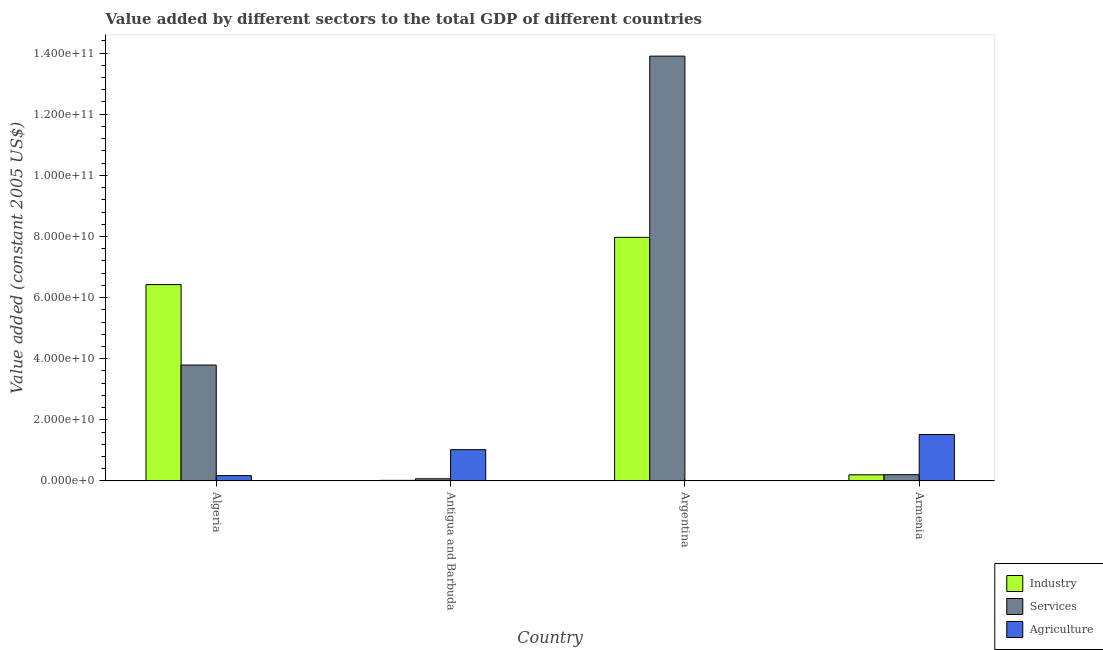How many bars are there on the 4th tick from the left?
Make the answer very short. 3. How many bars are there on the 1st tick from the right?
Offer a very short reply. 3. What is the label of the 4th group of bars from the left?
Make the answer very short. Armenia. What is the value added by agricultural sector in Antigua and Barbuda?
Your answer should be very brief. 1.02e+1. Across all countries, what is the maximum value added by services?
Your answer should be compact. 1.39e+11. Across all countries, what is the minimum value added by services?
Your answer should be very brief. 7.27e+08. In which country was the value added by services maximum?
Your answer should be compact. Argentina. In which country was the value added by industrial sector minimum?
Offer a terse response. Antigua and Barbuda. What is the total value added by agricultural sector in the graph?
Provide a short and direct response. 2.72e+1. What is the difference between the value added by industrial sector in Algeria and that in Antigua and Barbuda?
Your response must be concise. 6.40e+1. What is the difference between the value added by industrial sector in Antigua and Barbuda and the value added by agricultural sector in Armenia?
Keep it short and to the point. -1.50e+1. What is the average value added by agricultural sector per country?
Provide a succinct answer. 6.81e+09. What is the difference between the value added by industrial sector and value added by services in Antigua and Barbuda?
Offer a very short reply. -5.24e+08. In how many countries, is the value added by services greater than 116000000000 US$?
Your answer should be very brief. 1. What is the ratio of the value added by industrial sector in Antigua and Barbuda to that in Argentina?
Your answer should be compact. 0. Is the value added by agricultural sector in Antigua and Barbuda less than that in Armenia?
Your answer should be compact. Yes. What is the difference between the highest and the second highest value added by services?
Make the answer very short. 1.01e+11. What is the difference between the highest and the lowest value added by industrial sector?
Your answer should be very brief. 7.95e+1. In how many countries, is the value added by services greater than the average value added by services taken over all countries?
Offer a very short reply. 1. Is the sum of the value added by agricultural sector in Algeria and Argentina greater than the maximum value added by industrial sector across all countries?
Your answer should be compact. No. What does the 1st bar from the left in Argentina represents?
Provide a short and direct response. Industry. What does the 2nd bar from the right in Armenia represents?
Your answer should be compact. Services. Is it the case that in every country, the sum of the value added by industrial sector and value added by services is greater than the value added by agricultural sector?
Keep it short and to the point. No. Are all the bars in the graph horizontal?
Make the answer very short. No. Are the values on the major ticks of Y-axis written in scientific E-notation?
Provide a succinct answer. Yes. What is the title of the graph?
Offer a very short reply. Value added by different sectors to the total GDP of different countries. Does "Primary education" appear as one of the legend labels in the graph?
Offer a very short reply. No. What is the label or title of the X-axis?
Provide a succinct answer. Country. What is the label or title of the Y-axis?
Make the answer very short. Value added (constant 2005 US$). What is the Value added (constant 2005 US$) of Industry in Algeria?
Offer a terse response. 6.43e+1. What is the Value added (constant 2005 US$) of Services in Algeria?
Ensure brevity in your answer.  3.79e+1. What is the Value added (constant 2005 US$) in Agriculture in Algeria?
Your response must be concise. 1.75e+09. What is the Value added (constant 2005 US$) in Industry in Antigua and Barbuda?
Your answer should be compact. 2.03e+08. What is the Value added (constant 2005 US$) of Services in Antigua and Barbuda?
Offer a very short reply. 7.27e+08. What is the Value added (constant 2005 US$) in Agriculture in Antigua and Barbuda?
Provide a succinct answer. 1.02e+1. What is the Value added (constant 2005 US$) in Industry in Argentina?
Your answer should be compact. 7.97e+1. What is the Value added (constant 2005 US$) in Services in Argentina?
Offer a terse response. 1.39e+11. What is the Value added (constant 2005 US$) of Agriculture in Argentina?
Ensure brevity in your answer.  1.51e+07. What is the Value added (constant 2005 US$) in Industry in Armenia?
Your answer should be very brief. 2.02e+09. What is the Value added (constant 2005 US$) of Services in Armenia?
Offer a terse response. 2.06e+09. What is the Value added (constant 2005 US$) of Agriculture in Armenia?
Your answer should be very brief. 1.52e+1. Across all countries, what is the maximum Value added (constant 2005 US$) of Industry?
Make the answer very short. 7.97e+1. Across all countries, what is the maximum Value added (constant 2005 US$) of Services?
Ensure brevity in your answer.  1.39e+11. Across all countries, what is the maximum Value added (constant 2005 US$) of Agriculture?
Your answer should be very brief. 1.52e+1. Across all countries, what is the minimum Value added (constant 2005 US$) in Industry?
Offer a terse response. 2.03e+08. Across all countries, what is the minimum Value added (constant 2005 US$) in Services?
Make the answer very short. 7.27e+08. Across all countries, what is the minimum Value added (constant 2005 US$) in Agriculture?
Give a very brief answer. 1.51e+07. What is the total Value added (constant 2005 US$) of Industry in the graph?
Your answer should be compact. 1.46e+11. What is the total Value added (constant 2005 US$) of Services in the graph?
Your answer should be very brief. 1.80e+11. What is the total Value added (constant 2005 US$) of Agriculture in the graph?
Provide a succinct answer. 2.72e+1. What is the difference between the Value added (constant 2005 US$) in Industry in Algeria and that in Antigua and Barbuda?
Ensure brevity in your answer.  6.40e+1. What is the difference between the Value added (constant 2005 US$) in Services in Algeria and that in Antigua and Barbuda?
Your answer should be very brief. 3.72e+1. What is the difference between the Value added (constant 2005 US$) of Agriculture in Algeria and that in Antigua and Barbuda?
Provide a succinct answer. -8.49e+09. What is the difference between the Value added (constant 2005 US$) of Industry in Algeria and that in Argentina?
Make the answer very short. -1.55e+1. What is the difference between the Value added (constant 2005 US$) of Services in Algeria and that in Argentina?
Make the answer very short. -1.01e+11. What is the difference between the Value added (constant 2005 US$) of Agriculture in Algeria and that in Argentina?
Make the answer very short. 1.74e+09. What is the difference between the Value added (constant 2005 US$) in Industry in Algeria and that in Armenia?
Make the answer very short. 6.22e+1. What is the difference between the Value added (constant 2005 US$) of Services in Algeria and that in Armenia?
Your response must be concise. 3.59e+1. What is the difference between the Value added (constant 2005 US$) in Agriculture in Algeria and that in Armenia?
Provide a short and direct response. -1.35e+1. What is the difference between the Value added (constant 2005 US$) of Industry in Antigua and Barbuda and that in Argentina?
Give a very brief answer. -7.95e+1. What is the difference between the Value added (constant 2005 US$) in Services in Antigua and Barbuda and that in Argentina?
Provide a succinct answer. -1.38e+11. What is the difference between the Value added (constant 2005 US$) in Agriculture in Antigua and Barbuda and that in Argentina?
Make the answer very short. 1.02e+1. What is the difference between the Value added (constant 2005 US$) of Industry in Antigua and Barbuda and that in Armenia?
Keep it short and to the point. -1.82e+09. What is the difference between the Value added (constant 2005 US$) in Services in Antigua and Barbuda and that in Armenia?
Provide a succinct answer. -1.34e+09. What is the difference between the Value added (constant 2005 US$) in Agriculture in Antigua and Barbuda and that in Armenia?
Provide a succinct answer. -4.96e+09. What is the difference between the Value added (constant 2005 US$) of Industry in Argentina and that in Armenia?
Ensure brevity in your answer.  7.77e+1. What is the difference between the Value added (constant 2005 US$) in Services in Argentina and that in Armenia?
Your response must be concise. 1.37e+11. What is the difference between the Value added (constant 2005 US$) of Agriculture in Argentina and that in Armenia?
Your response must be concise. -1.52e+1. What is the difference between the Value added (constant 2005 US$) of Industry in Algeria and the Value added (constant 2005 US$) of Services in Antigua and Barbuda?
Keep it short and to the point. 6.35e+1. What is the difference between the Value added (constant 2005 US$) of Industry in Algeria and the Value added (constant 2005 US$) of Agriculture in Antigua and Barbuda?
Keep it short and to the point. 5.40e+1. What is the difference between the Value added (constant 2005 US$) in Services in Algeria and the Value added (constant 2005 US$) in Agriculture in Antigua and Barbuda?
Give a very brief answer. 2.77e+1. What is the difference between the Value added (constant 2005 US$) of Industry in Algeria and the Value added (constant 2005 US$) of Services in Argentina?
Offer a very short reply. -7.48e+1. What is the difference between the Value added (constant 2005 US$) in Industry in Algeria and the Value added (constant 2005 US$) in Agriculture in Argentina?
Ensure brevity in your answer.  6.42e+1. What is the difference between the Value added (constant 2005 US$) of Services in Algeria and the Value added (constant 2005 US$) of Agriculture in Argentina?
Your response must be concise. 3.79e+1. What is the difference between the Value added (constant 2005 US$) in Industry in Algeria and the Value added (constant 2005 US$) in Services in Armenia?
Give a very brief answer. 6.22e+1. What is the difference between the Value added (constant 2005 US$) of Industry in Algeria and the Value added (constant 2005 US$) of Agriculture in Armenia?
Give a very brief answer. 4.90e+1. What is the difference between the Value added (constant 2005 US$) of Services in Algeria and the Value added (constant 2005 US$) of Agriculture in Armenia?
Your answer should be compact. 2.27e+1. What is the difference between the Value added (constant 2005 US$) in Industry in Antigua and Barbuda and the Value added (constant 2005 US$) in Services in Argentina?
Keep it short and to the point. -1.39e+11. What is the difference between the Value added (constant 2005 US$) of Industry in Antigua and Barbuda and the Value added (constant 2005 US$) of Agriculture in Argentina?
Offer a very short reply. 1.88e+08. What is the difference between the Value added (constant 2005 US$) in Services in Antigua and Barbuda and the Value added (constant 2005 US$) in Agriculture in Argentina?
Keep it short and to the point. 7.12e+08. What is the difference between the Value added (constant 2005 US$) in Industry in Antigua and Barbuda and the Value added (constant 2005 US$) in Services in Armenia?
Your response must be concise. -1.86e+09. What is the difference between the Value added (constant 2005 US$) in Industry in Antigua and Barbuda and the Value added (constant 2005 US$) in Agriculture in Armenia?
Your response must be concise. -1.50e+1. What is the difference between the Value added (constant 2005 US$) in Services in Antigua and Barbuda and the Value added (constant 2005 US$) in Agriculture in Armenia?
Your answer should be very brief. -1.45e+1. What is the difference between the Value added (constant 2005 US$) in Industry in Argentina and the Value added (constant 2005 US$) in Services in Armenia?
Provide a succinct answer. 7.77e+1. What is the difference between the Value added (constant 2005 US$) of Industry in Argentina and the Value added (constant 2005 US$) of Agriculture in Armenia?
Offer a terse response. 6.45e+1. What is the difference between the Value added (constant 2005 US$) of Services in Argentina and the Value added (constant 2005 US$) of Agriculture in Armenia?
Provide a short and direct response. 1.24e+11. What is the average Value added (constant 2005 US$) of Industry per country?
Your answer should be very brief. 3.65e+1. What is the average Value added (constant 2005 US$) in Services per country?
Offer a very short reply. 4.49e+1. What is the average Value added (constant 2005 US$) of Agriculture per country?
Your response must be concise. 6.81e+09. What is the difference between the Value added (constant 2005 US$) in Industry and Value added (constant 2005 US$) in Services in Algeria?
Keep it short and to the point. 2.63e+1. What is the difference between the Value added (constant 2005 US$) in Industry and Value added (constant 2005 US$) in Agriculture in Algeria?
Offer a very short reply. 6.25e+1. What is the difference between the Value added (constant 2005 US$) of Services and Value added (constant 2005 US$) of Agriculture in Algeria?
Offer a terse response. 3.62e+1. What is the difference between the Value added (constant 2005 US$) of Industry and Value added (constant 2005 US$) of Services in Antigua and Barbuda?
Your response must be concise. -5.24e+08. What is the difference between the Value added (constant 2005 US$) in Industry and Value added (constant 2005 US$) in Agriculture in Antigua and Barbuda?
Offer a very short reply. -1.00e+1. What is the difference between the Value added (constant 2005 US$) of Services and Value added (constant 2005 US$) of Agriculture in Antigua and Barbuda?
Your answer should be compact. -9.52e+09. What is the difference between the Value added (constant 2005 US$) of Industry and Value added (constant 2005 US$) of Services in Argentina?
Offer a terse response. -5.93e+1. What is the difference between the Value added (constant 2005 US$) in Industry and Value added (constant 2005 US$) in Agriculture in Argentina?
Your answer should be compact. 7.97e+1. What is the difference between the Value added (constant 2005 US$) of Services and Value added (constant 2005 US$) of Agriculture in Argentina?
Offer a terse response. 1.39e+11. What is the difference between the Value added (constant 2005 US$) of Industry and Value added (constant 2005 US$) of Services in Armenia?
Offer a very short reply. -4.50e+07. What is the difference between the Value added (constant 2005 US$) in Industry and Value added (constant 2005 US$) in Agriculture in Armenia?
Your response must be concise. -1.32e+1. What is the difference between the Value added (constant 2005 US$) in Services and Value added (constant 2005 US$) in Agriculture in Armenia?
Your response must be concise. -1.31e+1. What is the ratio of the Value added (constant 2005 US$) of Industry in Algeria to that in Antigua and Barbuda?
Keep it short and to the point. 315.97. What is the ratio of the Value added (constant 2005 US$) in Services in Algeria to that in Antigua and Barbuda?
Keep it short and to the point. 52.16. What is the ratio of the Value added (constant 2005 US$) of Agriculture in Algeria to that in Antigua and Barbuda?
Give a very brief answer. 0.17. What is the ratio of the Value added (constant 2005 US$) in Industry in Algeria to that in Argentina?
Give a very brief answer. 0.81. What is the ratio of the Value added (constant 2005 US$) of Services in Algeria to that in Argentina?
Your response must be concise. 0.27. What is the ratio of the Value added (constant 2005 US$) in Agriculture in Algeria to that in Argentina?
Give a very brief answer. 116.44. What is the ratio of the Value added (constant 2005 US$) of Industry in Algeria to that in Armenia?
Make the answer very short. 31.81. What is the ratio of the Value added (constant 2005 US$) in Services in Algeria to that in Armenia?
Your answer should be very brief. 18.37. What is the ratio of the Value added (constant 2005 US$) in Agriculture in Algeria to that in Armenia?
Your response must be concise. 0.12. What is the ratio of the Value added (constant 2005 US$) in Industry in Antigua and Barbuda to that in Argentina?
Ensure brevity in your answer.  0. What is the ratio of the Value added (constant 2005 US$) of Services in Antigua and Barbuda to that in Argentina?
Offer a terse response. 0.01. What is the ratio of the Value added (constant 2005 US$) in Agriculture in Antigua and Barbuda to that in Argentina?
Make the answer very short. 680.37. What is the ratio of the Value added (constant 2005 US$) of Industry in Antigua and Barbuda to that in Armenia?
Offer a terse response. 0.1. What is the ratio of the Value added (constant 2005 US$) in Services in Antigua and Barbuda to that in Armenia?
Give a very brief answer. 0.35. What is the ratio of the Value added (constant 2005 US$) of Agriculture in Antigua and Barbuda to that in Armenia?
Make the answer very short. 0.67. What is the ratio of the Value added (constant 2005 US$) of Industry in Argentina to that in Armenia?
Provide a succinct answer. 39.47. What is the ratio of the Value added (constant 2005 US$) of Services in Argentina to that in Armenia?
Provide a succinct answer. 67.32. What is the difference between the highest and the second highest Value added (constant 2005 US$) of Industry?
Give a very brief answer. 1.55e+1. What is the difference between the highest and the second highest Value added (constant 2005 US$) in Services?
Make the answer very short. 1.01e+11. What is the difference between the highest and the second highest Value added (constant 2005 US$) of Agriculture?
Provide a succinct answer. 4.96e+09. What is the difference between the highest and the lowest Value added (constant 2005 US$) of Industry?
Make the answer very short. 7.95e+1. What is the difference between the highest and the lowest Value added (constant 2005 US$) in Services?
Your answer should be compact. 1.38e+11. What is the difference between the highest and the lowest Value added (constant 2005 US$) in Agriculture?
Give a very brief answer. 1.52e+1. 